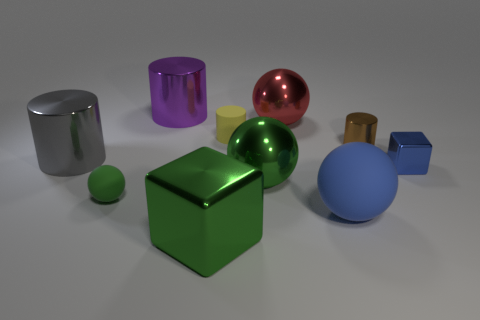What number of shiny spheres are left of the metallic cube that is in front of the shiny block to the right of the big green shiny sphere? There are no shiny spheres located to the left of the metallic cube depicted in the image. The cube itself is situated in front of a shiny block, which is to the right of the large green glossy sphere. 